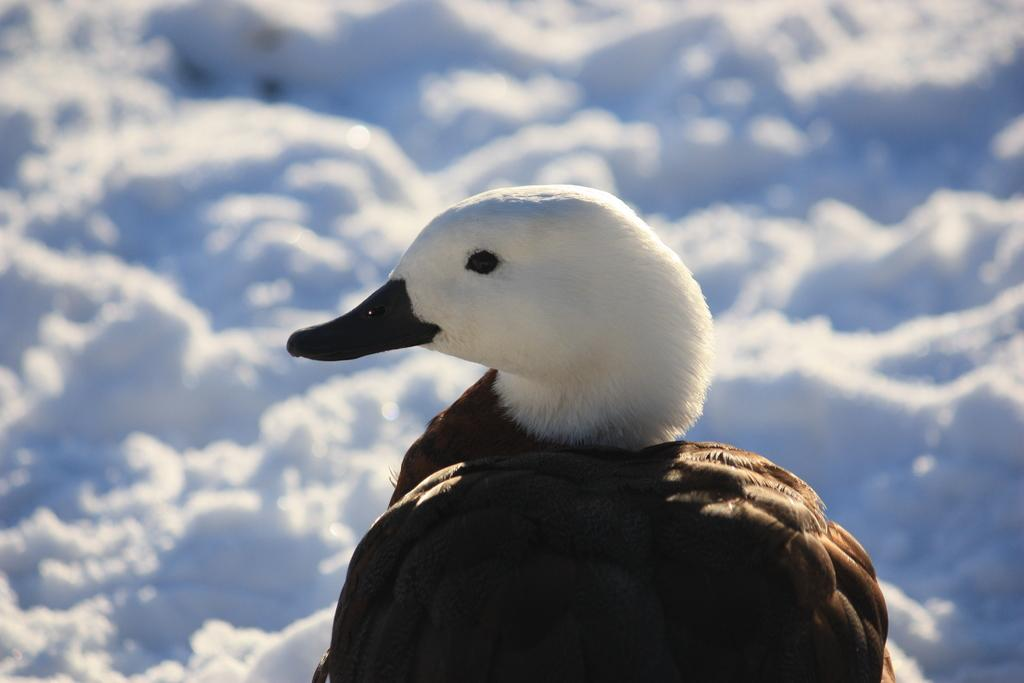What type of animal is present in the image? There is a bird in the image. What is the setting of the image? The background of the image contains snow. How is the background of the image depicted? The background of the image is blurred. What type of oil is being used by the bird in the image? There is no oil present in the image, and the bird is not using any oil. 